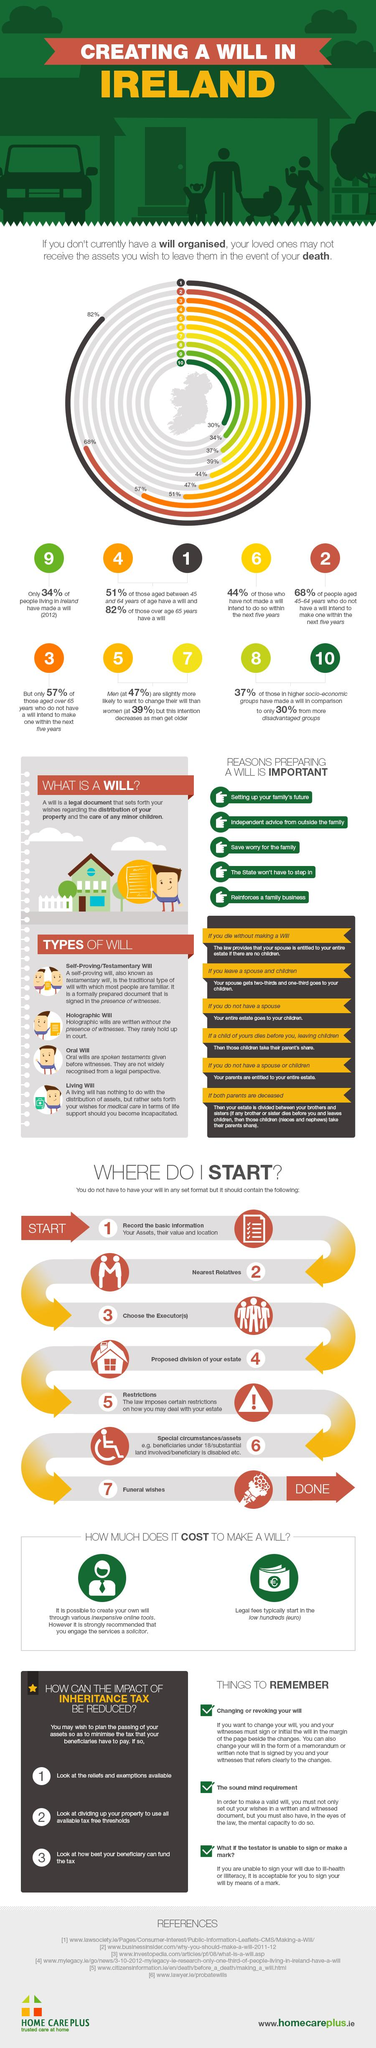Mention a couple of crucial points in this snapshot. A self-proving/testamentary will is signed in the presence of witnesses. Parents are entitled to an individual's estate when there is no spouse or children in the case where there is no legal heir or next of kin. Preparing a will is listed third as a reason to alleviate the worry for the family. The beneficiaries are required to pay inheritance tax. 